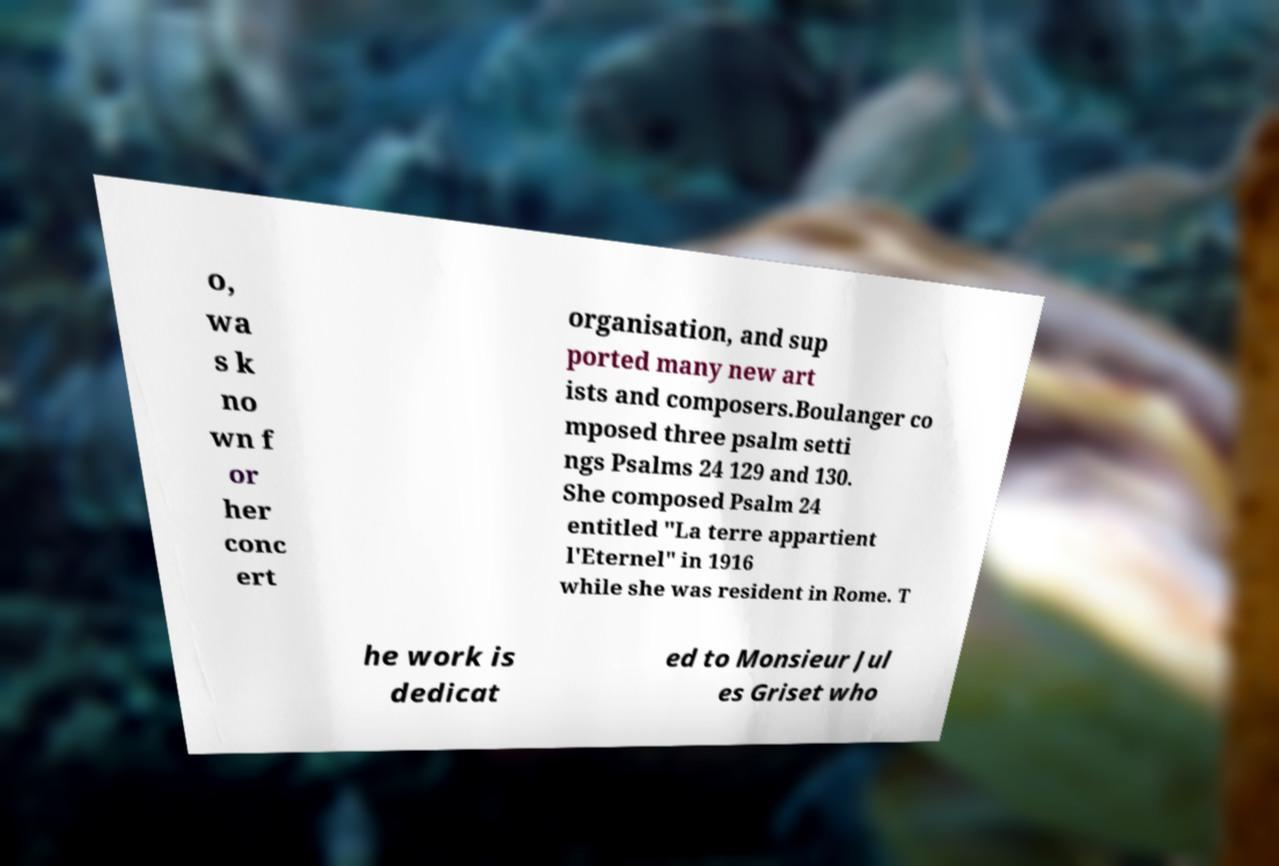Could you extract and type out the text from this image? o, wa s k no wn f or her conc ert organisation, and sup ported many new art ists and composers.Boulanger co mposed three psalm setti ngs Psalms 24 129 and 130. She composed Psalm 24 entitled "La terre appartient l'Eternel" in 1916 while she was resident in Rome. T he work is dedicat ed to Monsieur Jul es Griset who 